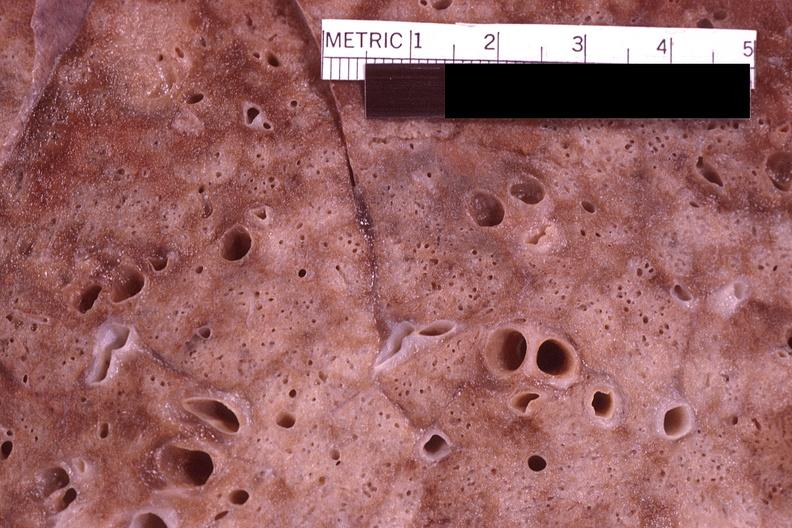where is this?
Answer the question using a single word or phrase. Lung 